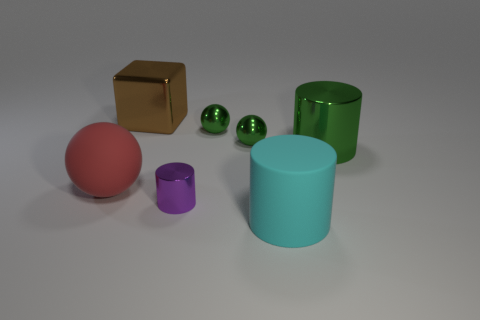Add 1 red balls. How many objects exist? 8 Subtract all cubes. How many objects are left? 6 Subtract 0 yellow blocks. How many objects are left? 7 Subtract all big green metal things. Subtract all big cyan rubber things. How many objects are left? 5 Add 2 red rubber balls. How many red rubber balls are left? 3 Add 5 large metallic objects. How many large metallic objects exist? 7 